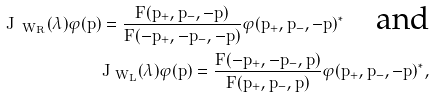Convert formula to latex. <formula><loc_0><loc_0><loc_500><loc_500>J _ { \ W _ { R } } ( \lambda ) \varphi ( p ) = \frac { F ( p _ { + } , p _ { - } , - \hat { p } ) } { F ( - p _ { + } , - p _ { - } , - \hat { p } ) } \varphi ( p _ { + } , p _ { - } , - \hat { p } ) ^ { * } \quad \text {and} \\ J _ { \ W _ { L } } ( \lambda ) \varphi ( p ) = \frac { F ( - p _ { + } , - p _ { - } , \hat { p } ) } { F ( p _ { + } , p _ { - } , \hat { p } ) } \varphi ( p _ { + } , p _ { - } , - \hat { p } ) ^ { * } ,</formula> 